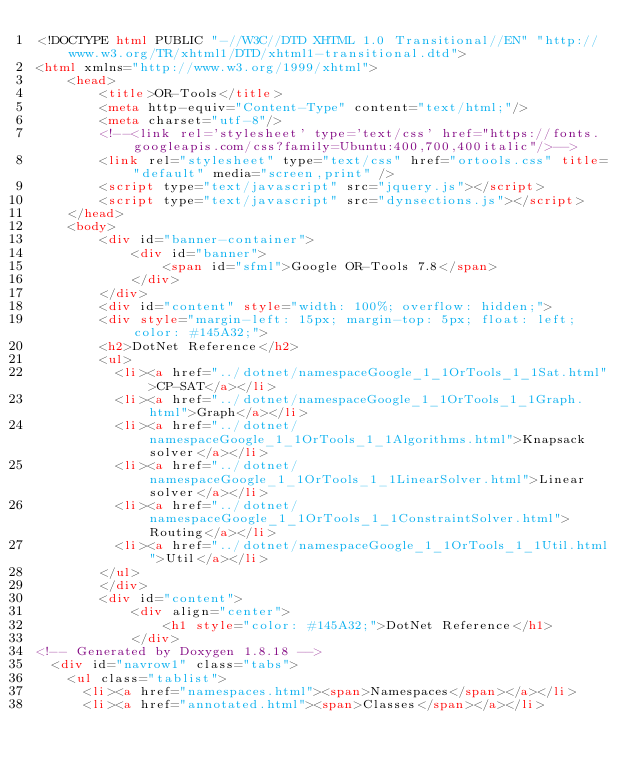Convert code to text. <code><loc_0><loc_0><loc_500><loc_500><_HTML_><!DOCTYPE html PUBLIC "-//W3C//DTD XHTML 1.0 Transitional//EN" "http://www.w3.org/TR/xhtml1/DTD/xhtml1-transitional.dtd">
<html xmlns="http://www.w3.org/1999/xhtml">
    <head>
        <title>OR-Tools</title>
        <meta http-equiv="Content-Type" content="text/html;"/>
        <meta charset="utf-8"/>
        <!--<link rel='stylesheet' type='text/css' href="https://fonts.googleapis.com/css?family=Ubuntu:400,700,400italic"/>-->
        <link rel="stylesheet" type="text/css" href="ortools.css" title="default" media="screen,print" />
        <script type="text/javascript" src="jquery.js"></script>
        <script type="text/javascript" src="dynsections.js"></script>
    </head>
    <body>
        <div id="banner-container">
            <div id="banner">
                <span id="sfml">Google OR-Tools 7.8</span>
            </div>
        </div>
        <div id="content" style="width: 100%; overflow: hidden;">
        <div style="margin-left: 15px; margin-top: 5px; float: left; color: #145A32;">
        <h2>DotNet Reference</h2>
        <ul>
          <li><a href="../dotnet/namespaceGoogle_1_1OrTools_1_1Sat.html">CP-SAT</a></li>
          <li><a href="../dotnet/namespaceGoogle_1_1OrTools_1_1Graph.html">Graph</a></li>
          <li><a href="../dotnet/namespaceGoogle_1_1OrTools_1_1Algorithms.html">Knapsack solver</a></li>
          <li><a href="../dotnet/namespaceGoogle_1_1OrTools_1_1LinearSolver.html">Linear solver</a></li>
          <li><a href="../dotnet/namespaceGoogle_1_1OrTools_1_1ConstraintSolver.html">Routing</a></li>
          <li><a href="../dotnet/namespaceGoogle_1_1OrTools_1_1Util.html">Util</a></li>
        </ul>
        </div>
        <div id="content">
            <div align="center">
                <h1 style="color: #145A32;">DotNet Reference</h1>
            </div>
<!-- Generated by Doxygen 1.8.18 -->
  <div id="navrow1" class="tabs">
    <ul class="tablist">
      <li><a href="namespaces.html"><span>Namespaces</span></a></li>
      <li><a href="annotated.html"><span>Classes</span></a></li></code> 